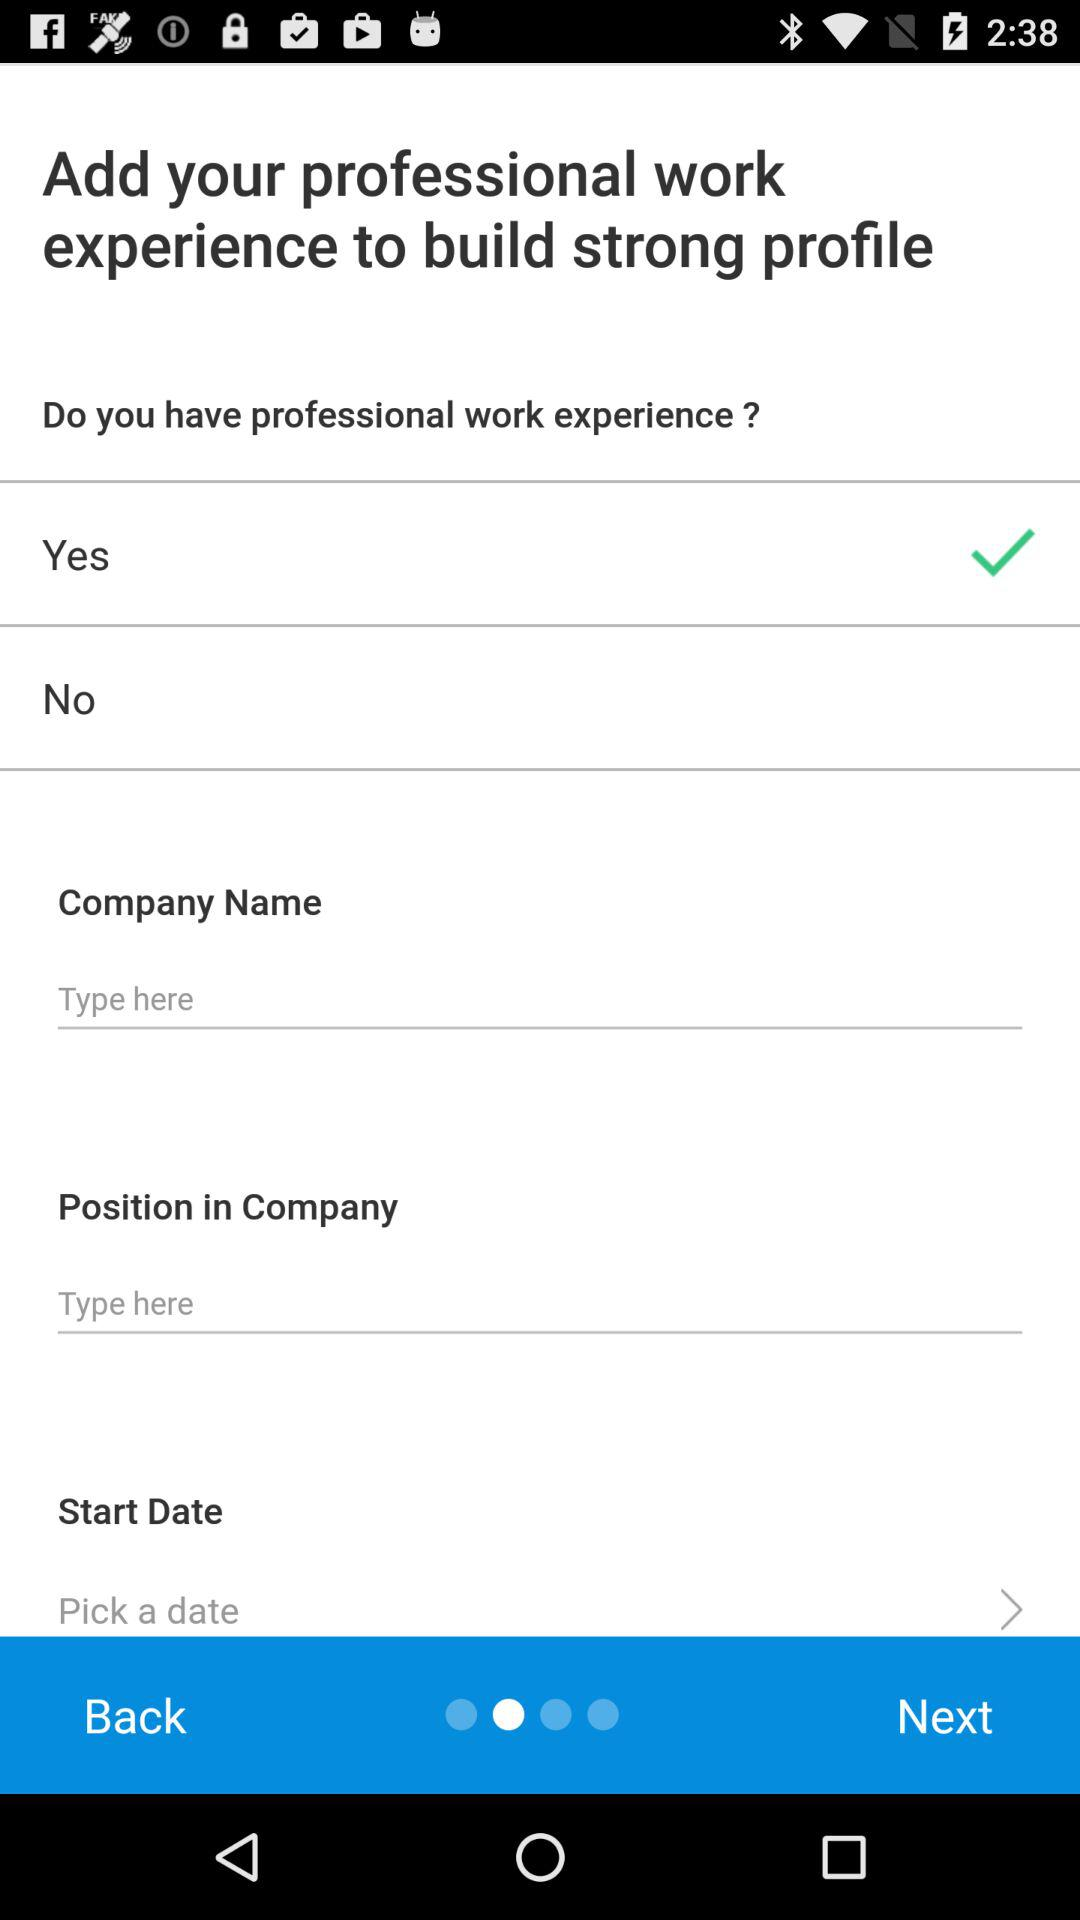How many items do you need to fill out to add your professional work experience?
Answer the question using a single word or phrase. 4 